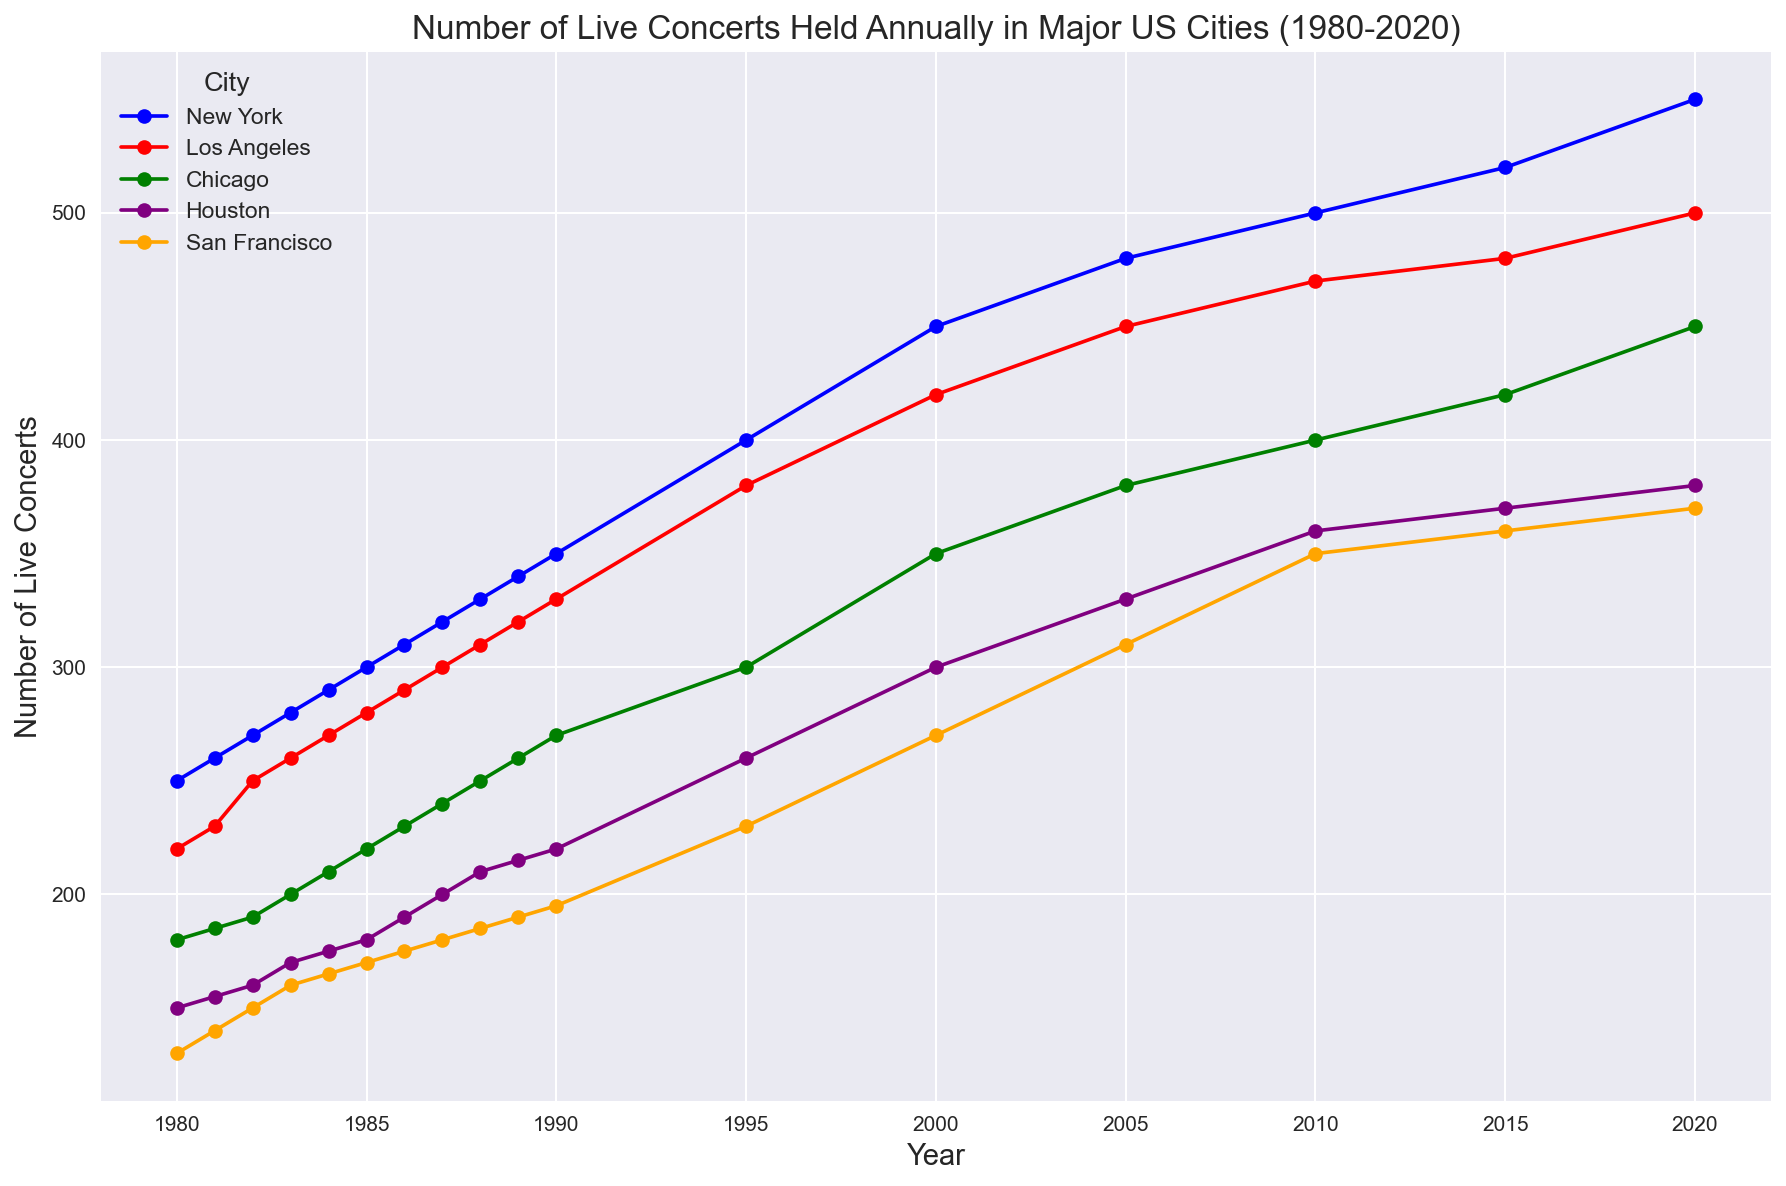Which city had the highest number of live concerts in 2020? Looking at the plot for the year 2020, the city with the line ending at the highest y-axis value represents the highest number of live concerts.
Answer: New York Which city showed the biggest increase in the number of live concerts from 1980 to 2020? To determine the biggest increase, subtract the 1980 value from the 2020 value for each city. The city with the highest result had the biggest increase.
Answer: New York How many more live concerts were held in Los Angeles compared to San Francisco in 2010? Find the data points for Los Angeles and San Francisco in 2010 from the plot. Subtract San Francisco's value from Los Angeles's value.
Answer: 120 Which city had the smallest number of live concerts in 1985? Look at the data points in 1985 and identify the city with the line at the lowest y-axis value.
Answer: San Francisco What's the average number of live concerts held in Chicago between 2000 and 2020? Locate the points for Chicago in 2000, 2005, 2010, 2015, and 2020, sum these values and divide by the number of years (5).
Answer: 400 In what year did New York first surpass 400 live concerts? Locate the Year axis along with New York line and find the first point where it crosses above 400 on the y-axis.
Answer: 1995 Comparing the trends, which city had a more rapid growth in live concerts between 1980 and 2020, Houston or Chicago? Look at the slopes of the lines for Houston and Chicago between 1980 and 2020. The city with the steeper slope experienced more rapid growth.
Answer: Chicago Did any city experience a decline in the number of live concerts between 1989 and 1990? Check the lines for each city from 1989 to 1990 and see if any lines drop.
Answer: No During which decade did San Francisco experience the most significant increase in live concerts? Observe the changes in San Francisco's plot line between each decade (1980s, 1990s, 2000s, 2010s), and identify the decade with the steepest increase.
Answer: 1990s How many cities had over 450 live concerts in 2020? Look at the end points in 2020 and count the number of lines above the 450 mark on the y-axis.
Answer: 3 